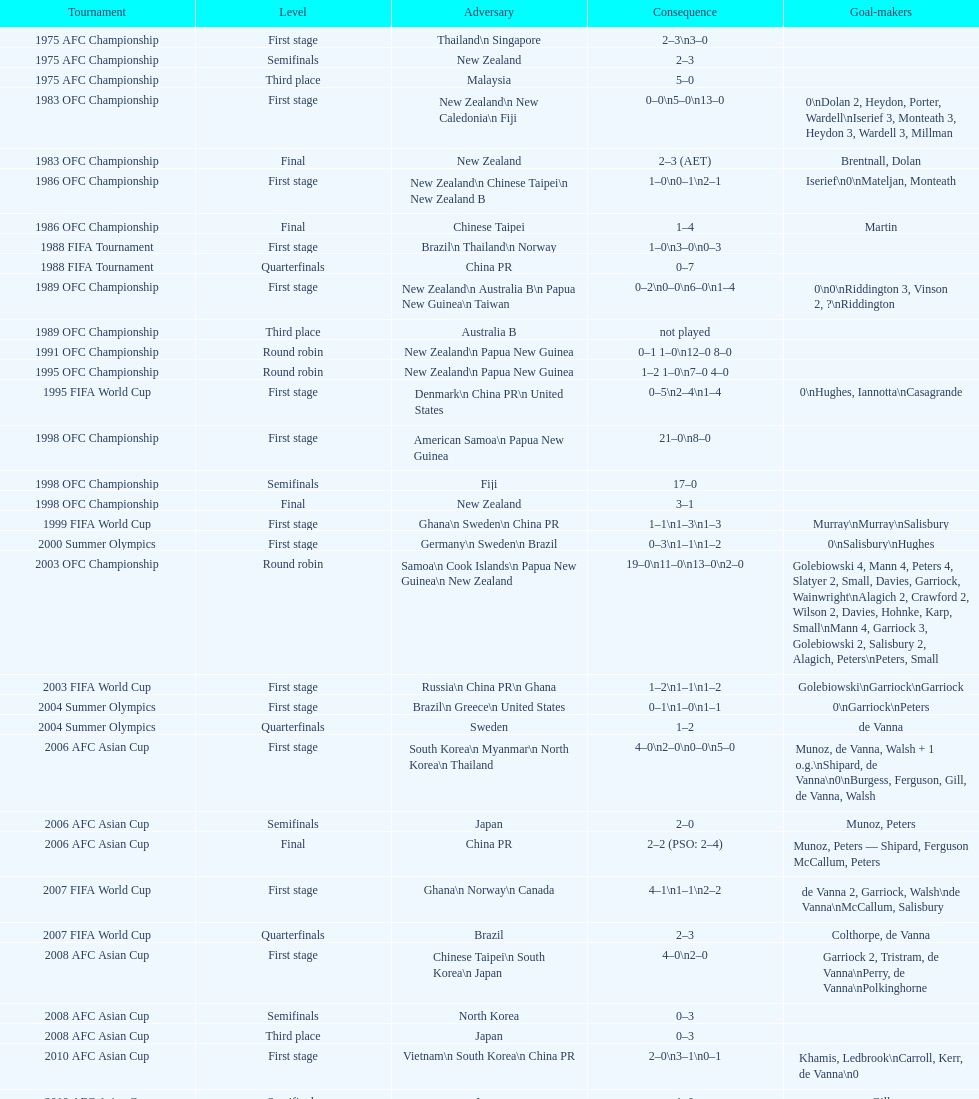Would you be able to parse every entry in this table? {'header': ['Tournament', 'Level', 'Adversary', 'Consequence', 'Goal-makers'], 'rows': [['1975 AFC Championship', 'First stage', 'Thailand\\n\xa0Singapore', '2–3\\n3–0', ''], ['1975 AFC Championship', 'Semifinals', 'New Zealand', '2–3', ''], ['1975 AFC Championship', 'Third place', 'Malaysia', '5–0', ''], ['1983 OFC Championship', 'First stage', 'New Zealand\\n\xa0New Caledonia\\n\xa0Fiji', '0–0\\n5–0\\n13–0', '0\\nDolan 2, Heydon, Porter, Wardell\\nIserief 3, Monteath 3, Heydon 3, Wardell 3, Millman'], ['1983 OFC Championship', 'Final', 'New Zealand', '2–3 (AET)', 'Brentnall, Dolan'], ['1986 OFC Championship', 'First stage', 'New Zealand\\n\xa0Chinese Taipei\\n New Zealand B', '1–0\\n0–1\\n2–1', 'Iserief\\n0\\nMateljan, Monteath'], ['1986 OFC Championship', 'Final', 'Chinese Taipei', '1–4', 'Martin'], ['1988 FIFA Tournament', 'First stage', 'Brazil\\n\xa0Thailand\\n\xa0Norway', '1–0\\n3–0\\n0–3', ''], ['1988 FIFA Tournament', 'Quarterfinals', 'China PR', '0–7', ''], ['1989 OFC Championship', 'First stage', 'New Zealand\\n Australia B\\n\xa0Papua New Guinea\\n\xa0Taiwan', '0–2\\n0–0\\n6–0\\n1–4', '0\\n0\\nRiddington 3, Vinson 2,\xa0?\\nRiddington'], ['1989 OFC Championship', 'Third place', 'Australia B', 'not played', ''], ['1991 OFC Championship', 'Round robin', 'New Zealand\\n\xa0Papua New Guinea', '0–1 1–0\\n12–0 8–0', ''], ['1995 OFC Championship', 'Round robin', 'New Zealand\\n\xa0Papua New Guinea', '1–2 1–0\\n7–0 4–0', ''], ['1995 FIFA World Cup', 'First stage', 'Denmark\\n\xa0China PR\\n\xa0United States', '0–5\\n2–4\\n1–4', '0\\nHughes, Iannotta\\nCasagrande'], ['1998 OFC Championship', 'First stage', 'American Samoa\\n\xa0Papua New Guinea', '21–0\\n8–0', ''], ['1998 OFC Championship', 'Semifinals', 'Fiji', '17–0', ''], ['1998 OFC Championship', 'Final', 'New Zealand', '3–1', ''], ['1999 FIFA World Cup', 'First stage', 'Ghana\\n\xa0Sweden\\n\xa0China PR', '1–1\\n1–3\\n1–3', 'Murray\\nMurray\\nSalisbury'], ['2000 Summer Olympics', 'First stage', 'Germany\\n\xa0Sweden\\n\xa0Brazil', '0–3\\n1–1\\n1–2', '0\\nSalisbury\\nHughes'], ['2003 OFC Championship', 'Round robin', 'Samoa\\n\xa0Cook Islands\\n\xa0Papua New Guinea\\n\xa0New Zealand', '19–0\\n11–0\\n13–0\\n2–0', 'Golebiowski 4, Mann 4, Peters 4, Slatyer 2, Small, Davies, Garriock, Wainwright\\nAlagich 2, Crawford 2, Wilson 2, Davies, Hohnke, Karp, Small\\nMann 4, Garriock 3, Golebiowski 2, Salisbury 2, Alagich, Peters\\nPeters, Small'], ['2003 FIFA World Cup', 'First stage', 'Russia\\n\xa0China PR\\n\xa0Ghana', '1–2\\n1–1\\n1–2', 'Golebiowski\\nGarriock\\nGarriock'], ['2004 Summer Olympics', 'First stage', 'Brazil\\n\xa0Greece\\n\xa0United States', '0–1\\n1–0\\n1–1', '0\\nGarriock\\nPeters'], ['2004 Summer Olympics', 'Quarterfinals', 'Sweden', '1–2', 'de Vanna'], ['2006 AFC Asian Cup', 'First stage', 'South Korea\\n\xa0Myanmar\\n\xa0North Korea\\n\xa0Thailand', '4–0\\n2–0\\n0–0\\n5–0', 'Munoz, de Vanna, Walsh + 1 o.g.\\nShipard, de Vanna\\n0\\nBurgess, Ferguson, Gill, de Vanna, Walsh'], ['2006 AFC Asian Cup', 'Semifinals', 'Japan', '2–0', 'Munoz, Peters'], ['2006 AFC Asian Cup', 'Final', 'China PR', '2–2 (PSO: 2–4)', 'Munoz, Peters — Shipard, Ferguson McCallum, Peters'], ['2007 FIFA World Cup', 'First stage', 'Ghana\\n\xa0Norway\\n\xa0Canada', '4–1\\n1–1\\n2–2', 'de Vanna 2, Garriock, Walsh\\nde Vanna\\nMcCallum, Salisbury'], ['2007 FIFA World Cup', 'Quarterfinals', 'Brazil', '2–3', 'Colthorpe, de Vanna'], ['2008 AFC Asian Cup', 'First stage', 'Chinese Taipei\\n\xa0South Korea\\n\xa0Japan', '4–0\\n2–0', 'Garriock 2, Tristram, de Vanna\\nPerry, de Vanna\\nPolkinghorne'], ['2008 AFC Asian Cup', 'Semifinals', 'North Korea', '0–3', ''], ['2008 AFC Asian Cup', 'Third place', 'Japan', '0–3', ''], ['2010 AFC Asian Cup', 'First stage', 'Vietnam\\n\xa0South Korea\\n\xa0China PR', '2–0\\n3–1\\n0–1', 'Khamis, Ledbrook\\nCarroll, Kerr, de Vanna\\n0'], ['2010 AFC Asian Cup', 'Semifinals', 'Japan', '1–0', 'Gill'], ['2010 AFC Asian Cup', 'Final', 'North Korea', '1–1 (PSO: 5–4)', 'Kerr — PSO: Shipard, Ledbrook, Gill, Garriock, Simon'], ['2011 FIFA World Cup', 'First stage', 'Brazil\\n\xa0Equatorial Guinea\\n\xa0Norway', '0–1\\n3–2\\n2–1', '0\\nvan Egmond, Khamis, de Vanna\\nSimon 2'], ['2011 FIFA World Cup', 'Quarterfinals', 'Sweden', '1–3', 'Perry'], ['2012 Summer Olympics\\nAFC qualification', 'Final round', 'North Korea\\n\xa0Thailand\\n\xa0Japan\\n\xa0China PR\\n\xa0South Korea', '0–1\\n5–1\\n0–1\\n1–0\\n2–1', '0\\nHeyman 2, Butt, van Egmond, Simon\\n0\\nvan Egmond\\nButt, de Vanna'], ['2014 AFC Asian Cup', 'First stage', 'Japan\\n\xa0Jordan\\n\xa0Vietnam', 'TBD\\nTBD\\nTBD', '']]} What it the total number of countries in the first stage of the 2008 afc asian cup? 4. 